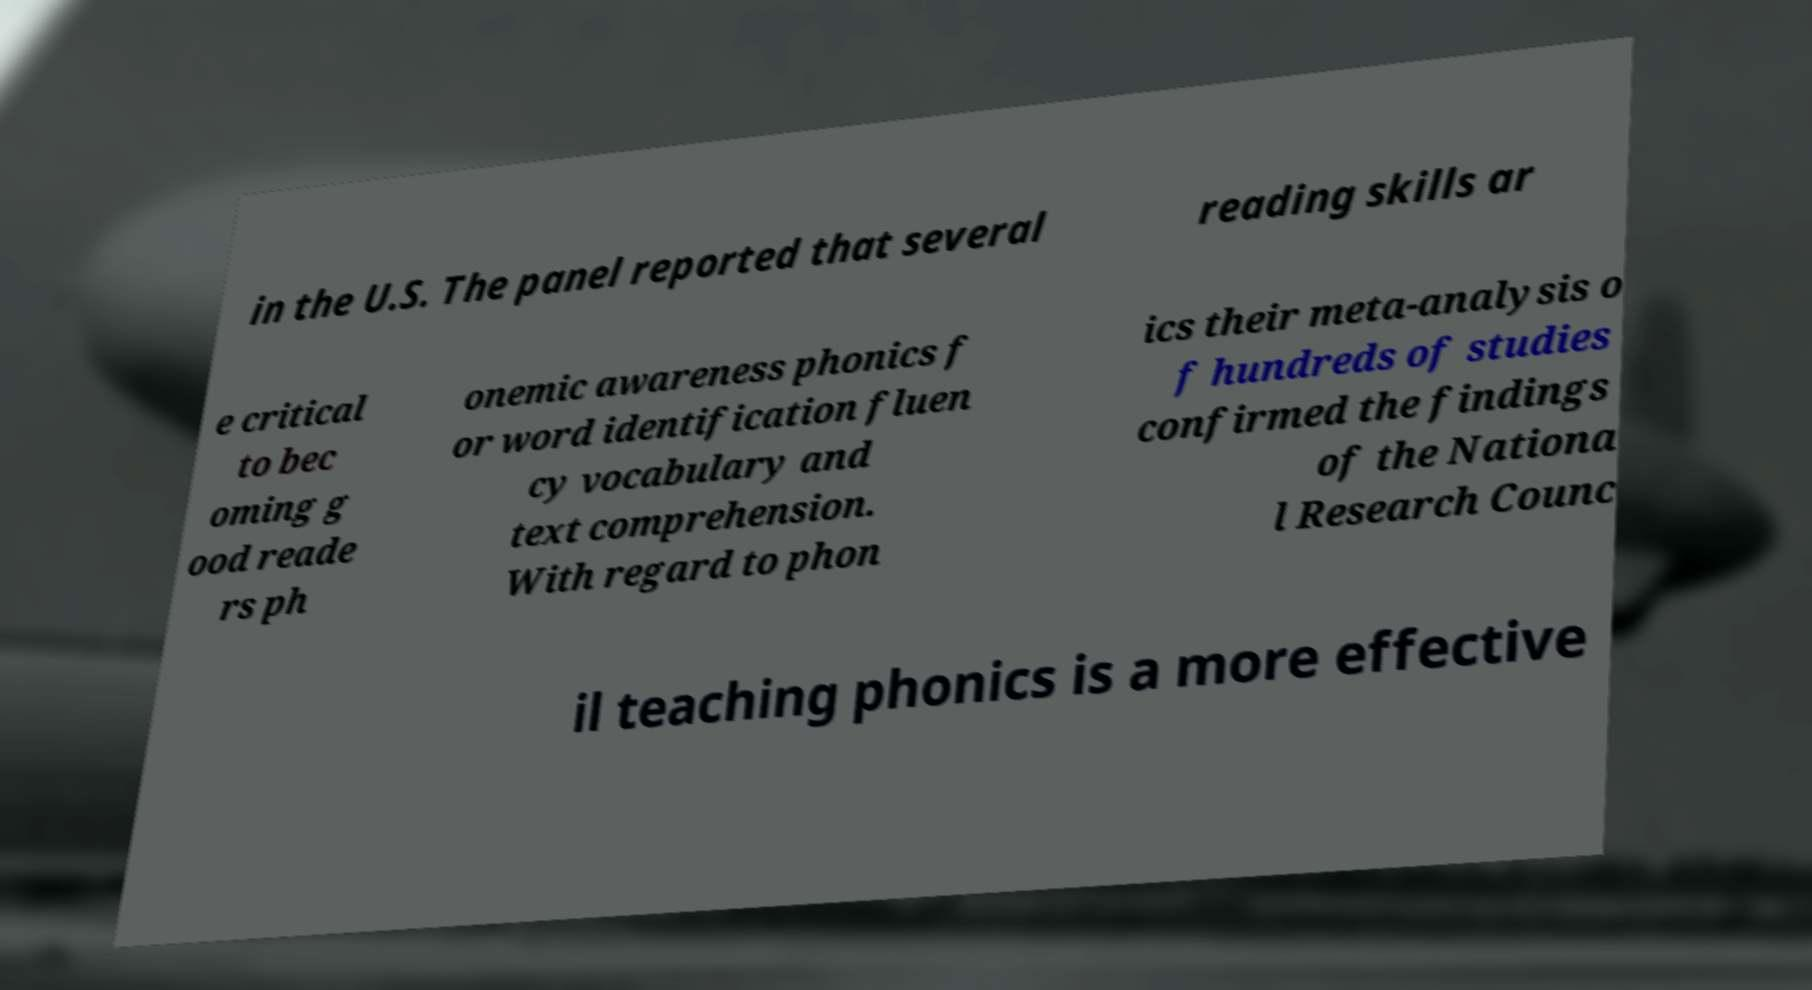Please identify and transcribe the text found in this image. in the U.S. The panel reported that several reading skills ar e critical to bec oming g ood reade rs ph onemic awareness phonics f or word identification fluen cy vocabulary and text comprehension. With regard to phon ics their meta-analysis o f hundreds of studies confirmed the findings of the Nationa l Research Counc il teaching phonics is a more effective 